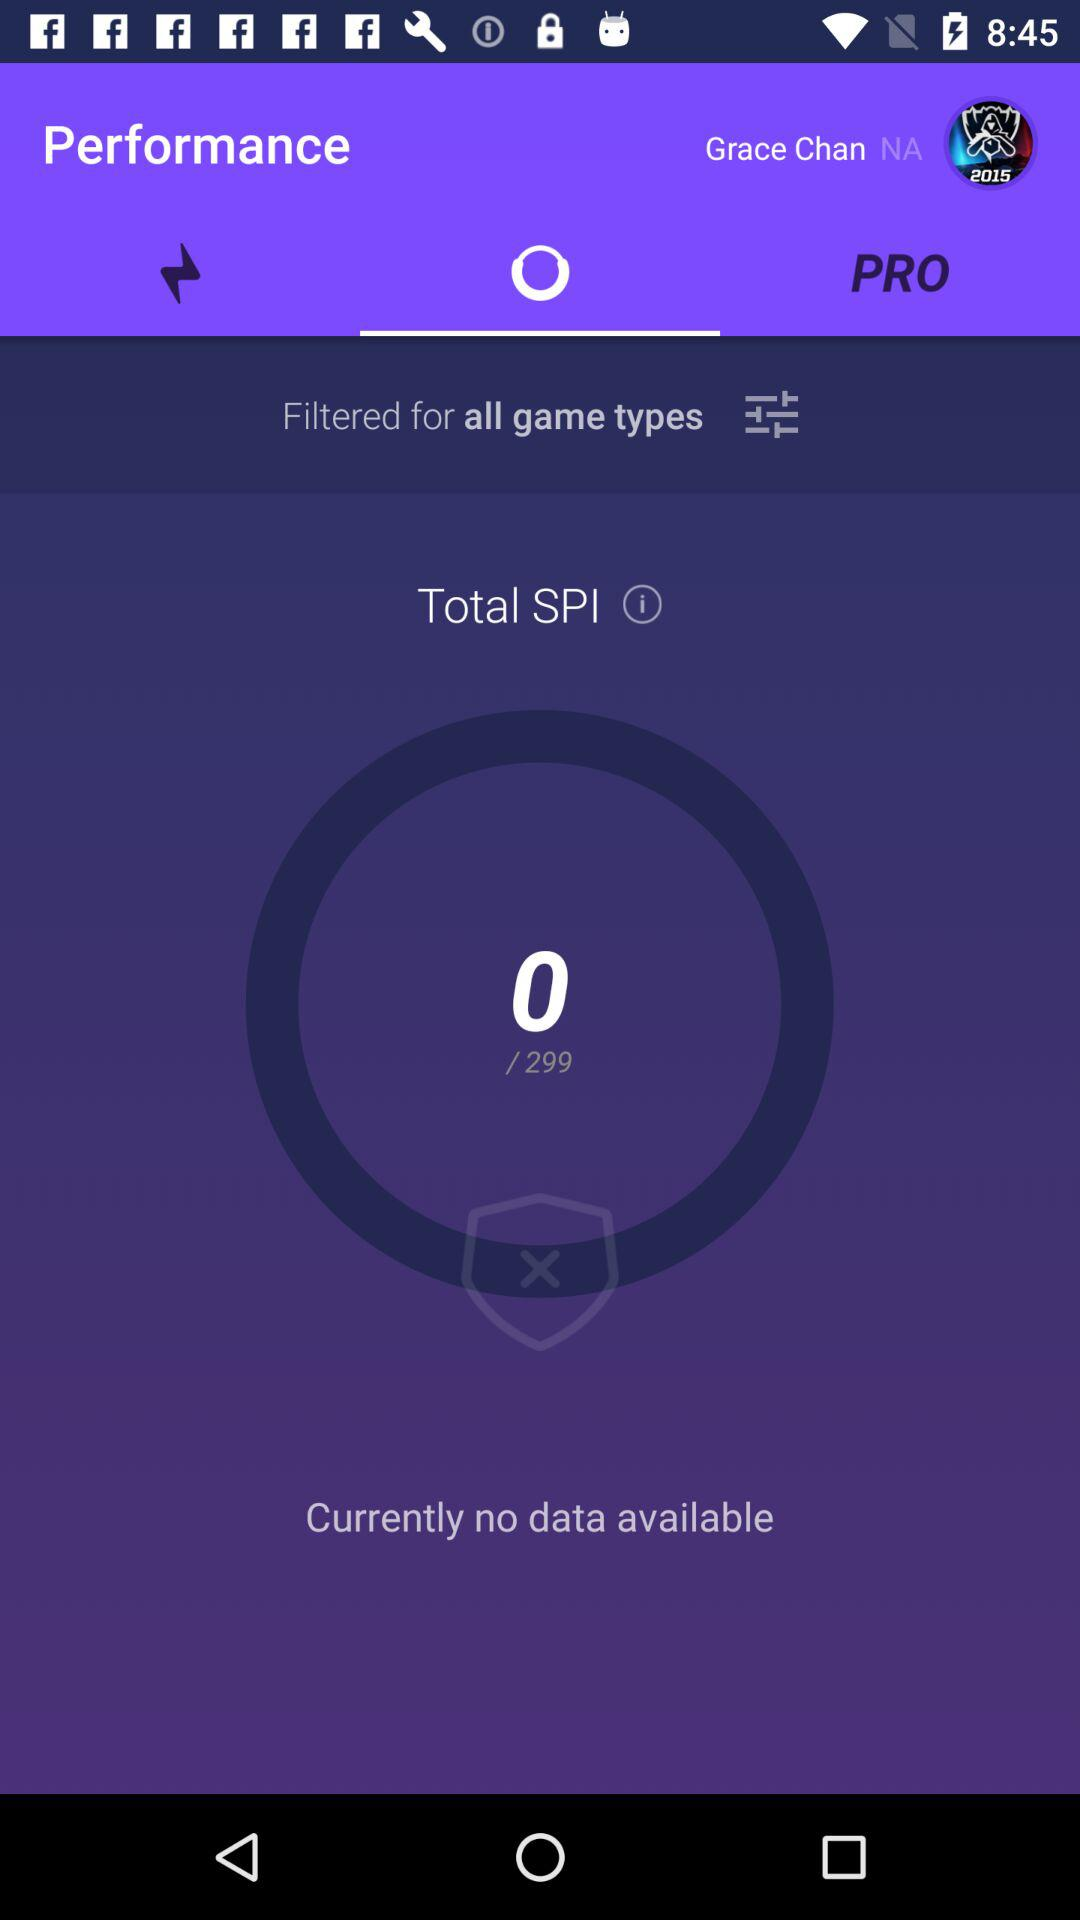At which SPI number are we right now? You are currently at SPI number 0. 